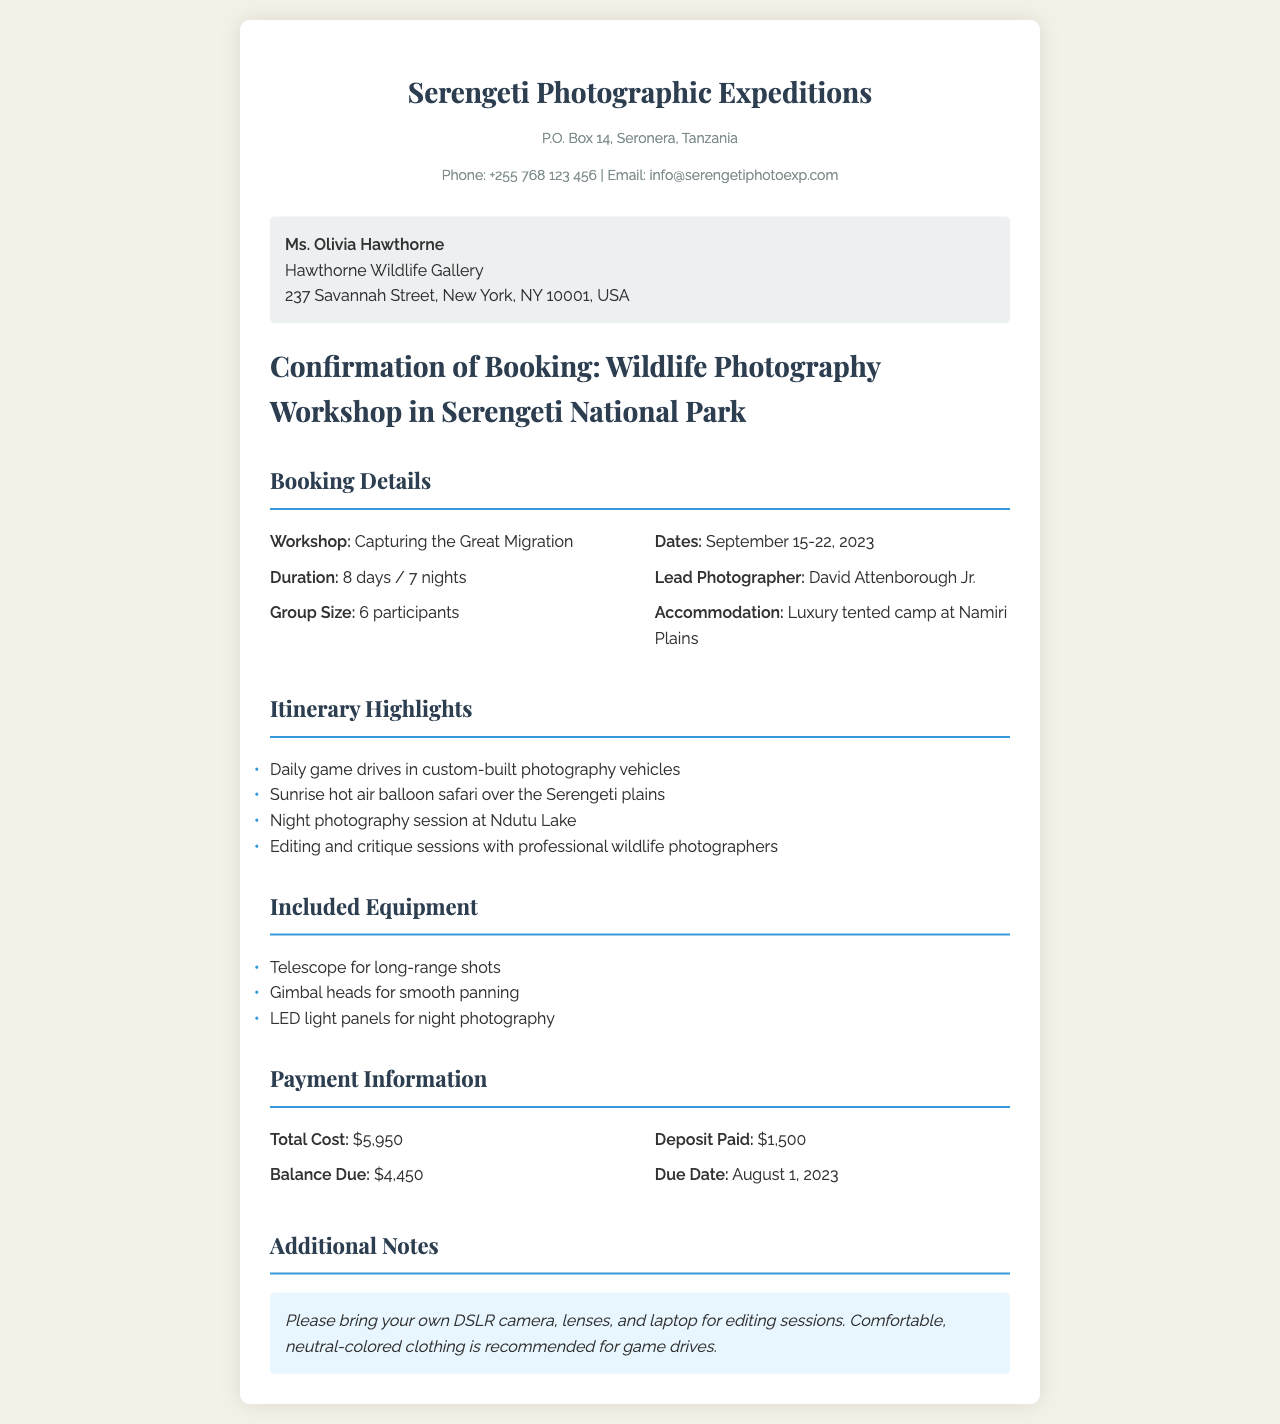What is the name of the workshop? The workshop's title is mentioned in the booking details section of the document.
Answer: Capturing the Great Migration What are the dates of the workshop? The specific dates for the workshop are clearly listed in the booking details section.
Answer: September 15-22, 2023 Who is the lead photographer for the workshop? The document specifies the lead photographer in the booking details.
Answer: David Attenborough Jr What is the total cost of the workshop? The total cost is found in the payment information section of the document.
Answer: $5,950 How many participants are in the group size? The group size is stated in the booking details section of the document.
Answer: 6 participants What is included in the itinerary highlights? The document provides a list of activities included in the itinerary.
Answer: Daily game drives, hot air balloon safari, night photography session, editing and critique sessions What is the balance due amount? The balance due is found in the payment information section of the document.
Answer: $4,450 What type of clothing is recommended for game drives? The document includes notes about recommended attire in the additional notes section.
Answer: Comfortable, neutral-colored clothing What is the accommodation for the workshop? The accommodation details are mentioned in the booking details section.
Answer: Luxury tented camp at Namiri Plains 